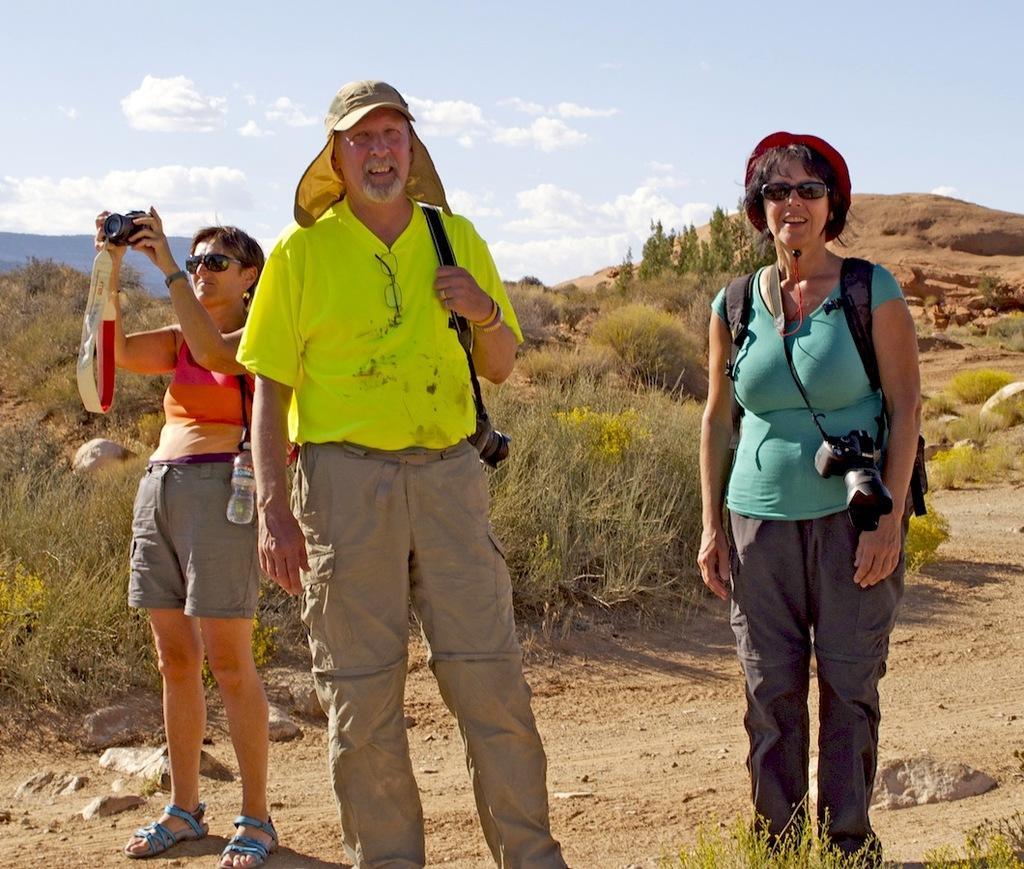How would you summarize this image in a sentence or two? In this image we can see three persons standing on the ground, a person is holding a camera and in the background there are few plants, trees and the sky with clouds. 